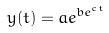<formula> <loc_0><loc_0><loc_500><loc_500>y ( t ) = a e ^ { b e ^ { c t } }</formula> 